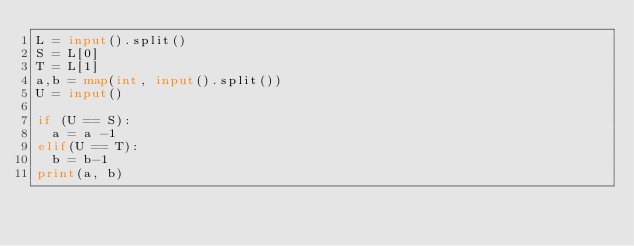Convert code to text. <code><loc_0><loc_0><loc_500><loc_500><_Python_>L = input().split()
S = L[0]
T = L[1]
a,b = map(int, input().split())
U = input()

if (U == S):
  a = a -1
elif(U == T):
  b = b-1
print(a, b)</code> 